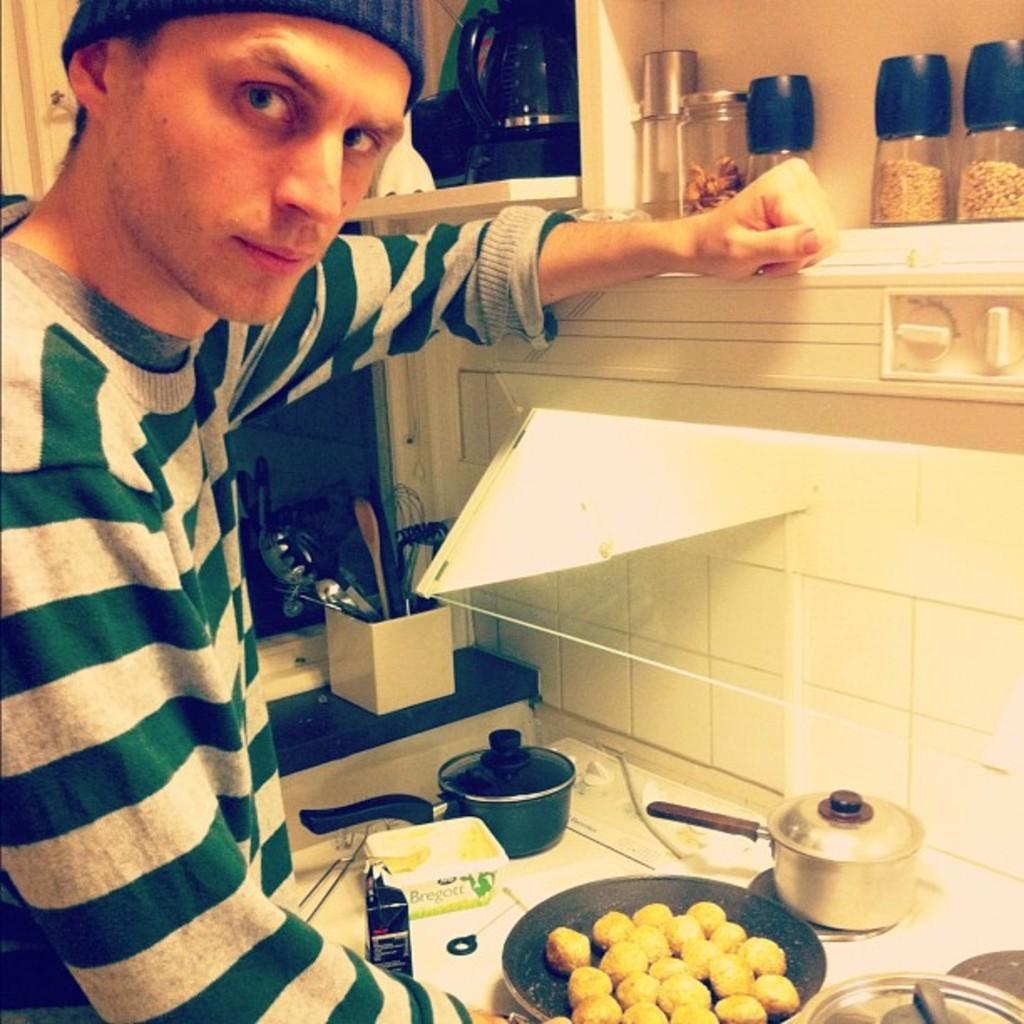Who is present in the image? There is a person in the image. What is the person wearing? The person is wearing a green and grey t-shirt. What can be seen in front of the person? There are utensils and food items in front of the person. What type of utensils are visible in the image? There are spoons in the image. What else can be seen in the image? There are jars in the image. What level of vacation is the person on in the image? There is no indication of a vacation in the image, so it is not possible to determine the person's vacation level. 